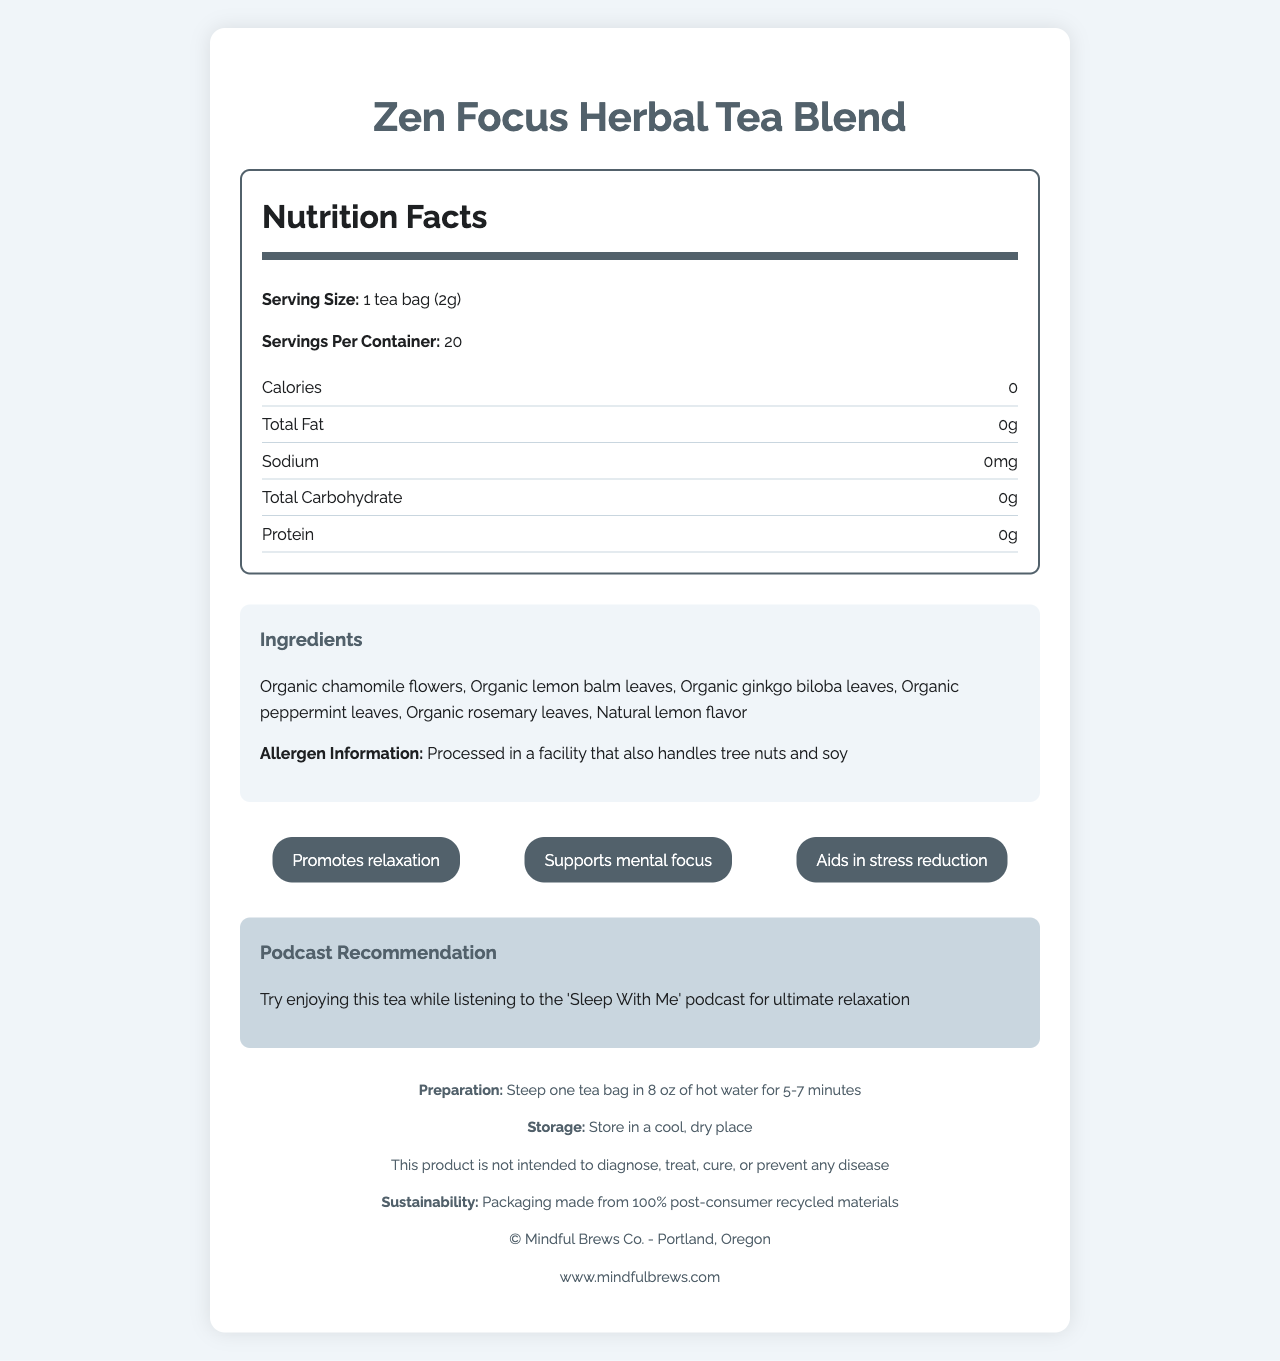what is the serving size? The serving size is listed as "1 tea bag (2g)" in the Nutrition Facts section.
Answer: 1 tea bag (2g) how many servings are in one container? The document states there are 20 servings per container in the Nutrition Facts section.
Answer: 20 what are the total calories per serving? The Nutrition Facts section indicates that the calories per serving are 0.
Answer: 0 does this product contain caffeine? The document mentions the health claim "Caffeine-free," indicating the product does not contain caffeine.
Answer: No what are the three primary benefits of this tea blend? These benefits are listed under the "benefits" section of the document.
Answer: Promotes relaxation, Supports mental focus, Aids in stress reduction what is the product name? A. Tranquil Tea B. Zen Focus Herbal Tea Blend C. Calm Moments Herbal Tea The document title and the container both say "Zen Focus Herbal Tea Blend."
Answer: B which ingredient gives the tea a lemony flavor? A. Organic chamomile flowers B. Organic rosemary leaves C. Natural lemon flavor The ingredient list includes "Natural lemon flavor," which gives the tea a lemony taste.
Answer: C how do you prepare this tea? The preparation instructions are provided in the footer section of the document.
Answer: Steep one tea bag in 8 oz of hot water for 5-7 minutes can you store the tea in a humid place? The storage instructions advise to "Store in a cool, dry place," indicating a humid place is unsuitable.
Answer: No what is the product's main purpose? The document overall highlights the product's benefits, such as promoting relaxation and mental focus, being caffeine-free, and containing no artificial flavors or preservatives.
Answer: The product is a caffeine-free herbal tea blend that promotes relaxation and mental focus, without using any artificial flavors or preservatives. how is the product's packaging environmentally friendly? The sustainability note in the footer of the document states the packaging is made from 100% post-consumer recycled materials.
Answer: Packaging made from 100% post-consumer recycled materials where is the company located? The footer section contains the company information, stating that Mindful Brews Co. is located in Portland, Oregon.
Answer: Portland, Oregon what allergens might this product contain? The allergen information provided lists that the tea is processed in a facility that handles tree nuts and soy.
Answer: Processed in a facility that also handles tree nuts and soy can this product cure diseases? The document includes a warning that states, "This product is not intended to diagnose, treat, cure, or prevent any disease."
Answer: No which of the following is not an ingredient in the tea blend? A. Organic chamomile flowers B. Organic lemon balm leaves C. Organic black tea leaves D. Organic peppermint leaves Organic black tea leaves are not listed among the ingredients of the tea blend.
Answer: C what can you pair with this tea to enhance relaxation? The podcast recommendation suggests enjoying the tea while listening to the 'Sleep With Me' podcast for ultimate relaxation.
Answer: The 'Sleep With Me' podcast are there any preservatives in this tea? One of the health claims is that the product contains "No artificial flavors or preservatives."
Answer: No does the tea blend include any artificial ingredients? The health claims state that the product has "No artificial flavors or preservatives."
Answer: No is this product certified organic? One of the health claims is "USDA Organic," indicating the product is certified organic.
Answer: Yes how many grams of protein does each serving contain? The Nutrition Facts section shows that the protein content per serving is 0g.
Answer: 0g does the document provide a podcast recommendation for horror fans? The document recommends a relaxation-focused podcast ('Sleep With Me'), not a horror podcast.
Answer: No 